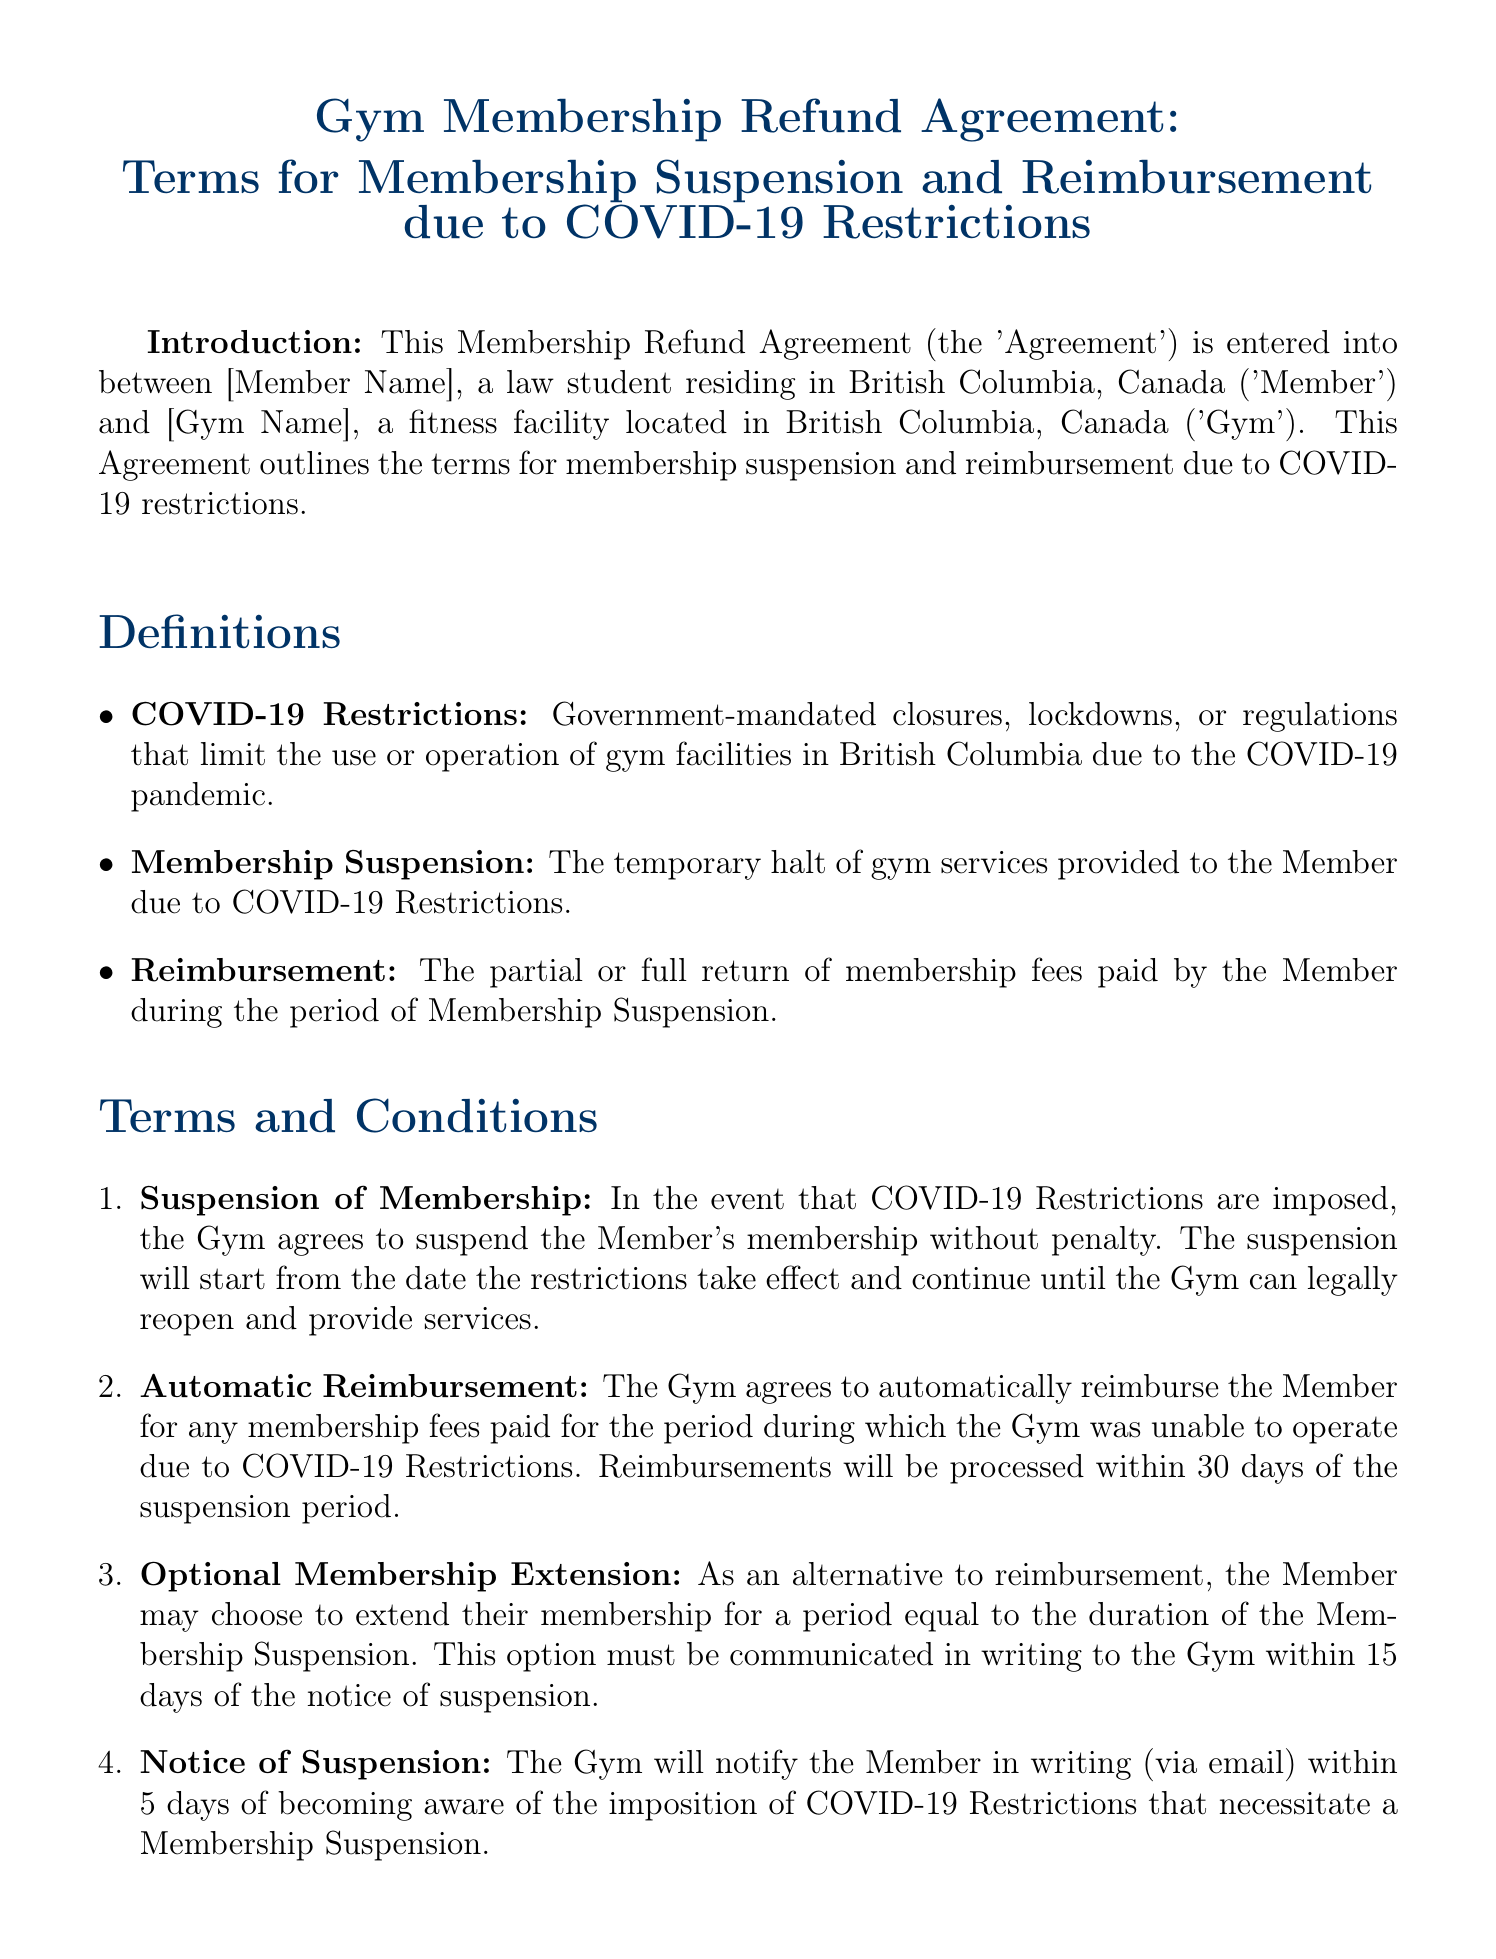What is the title of the agreement? The title of the agreement is the name given at the top of the document, which outlines the subject matter.
Answer: Gym Membership Refund Agreement: Terms for Membership Suspension and Reimbursement due to COVID-19 Restrictions Who is the member identified in the agreement? The document refers to the member as someone who has entered into the agreement but does not specify a name in the provided text.
Answer: [Member Name] What does "COVID-19 Restrictions" refer to? This term is defined in the document, specifying the nature of the restrictions affecting the gym's operations.
Answer: Government-mandated closures, lockdowns, or regulations How long does the gym have to process reimbursements? This time frame is specified in the terms regarding automatic reimbursement, which outlines the timeframe for financial processing.
Answer: 30 days What must the member do to obtain a membership extension instead of reimbursement? The document states the condition for choosing an extension over reimbursement, which involves notifying the gym.
Answer: Communicate in writing within 15 days What is the governing law of the agreement? This is specified in a section of the document that identifies legal jurisdiction.
Answer: The laws of the Province of British Columbia, Canada How long will the gym notify the member regarding the suspension due to COVID-19? The document outlines the timeframe for when the gym must inform the member about the suspension of services.
Answer: 5 days What does the term "Membership Suspension" mean? This term is defined in the document specifying the action taken concerning the member's gym services.
Answer: The temporary halt of gym services provided to the Member Who signs the agreement on behalf of the gym? The agreement includes a provision for a representative from the gym to sign, indicating who is authorized to finalize the contract.
Answer: [Gym Representative Name] 